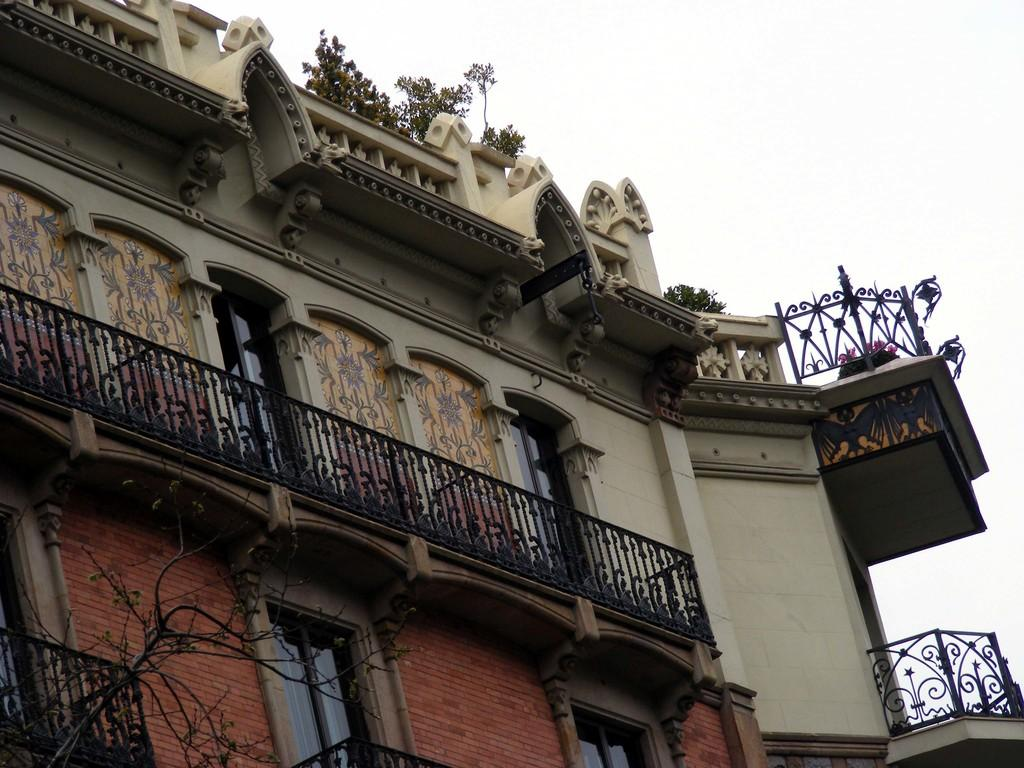What type of structure is present in the image? There is a building in the image. What are the main features of the building? The building has walls, windows, and railings. What other elements can be seen in the image besides the building? There are plants and tree stems in the image. What is visible in the background of the image? The sky is visible in the background of the image. Can you see a kettle boiling water in the image? There is no kettle present in the image. 